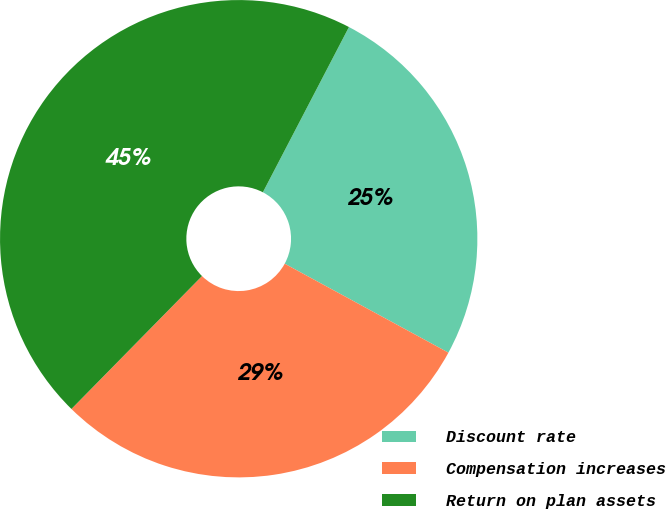Convert chart. <chart><loc_0><loc_0><loc_500><loc_500><pie_chart><fcel>Discount rate<fcel>Compensation increases<fcel>Return on plan assets<nl><fcel>25.28%<fcel>29.44%<fcel>45.29%<nl></chart> 